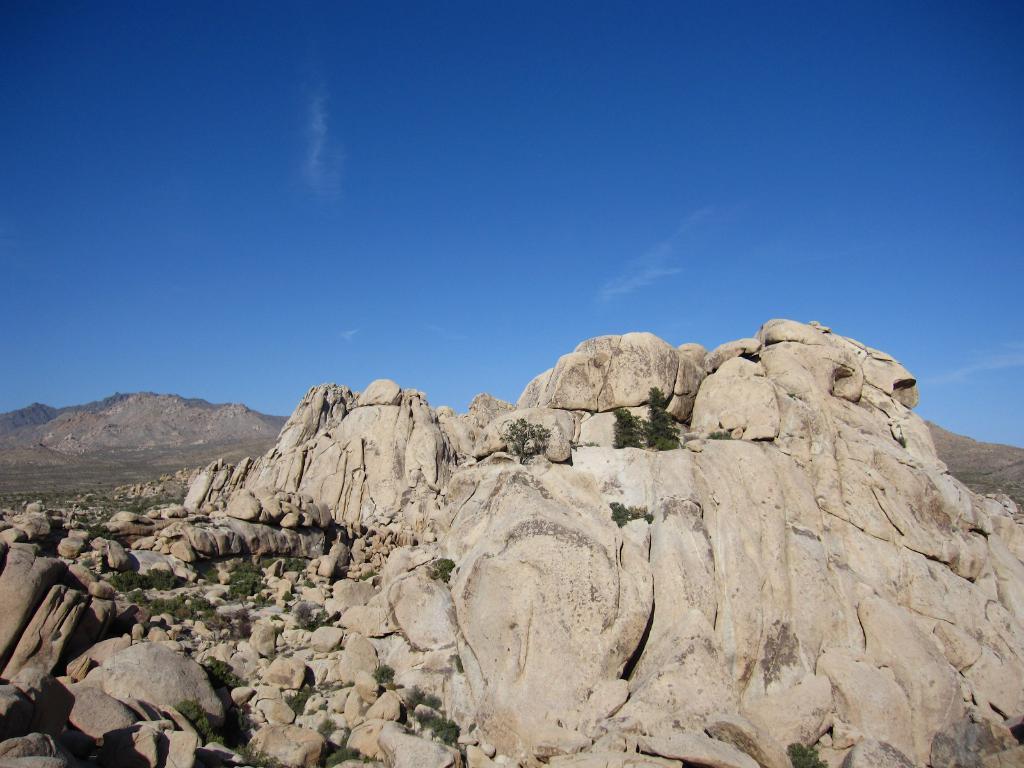Please provide a concise description of this image. In this picture I see the rocks in front and I see few plants. In the background I see the sky. 